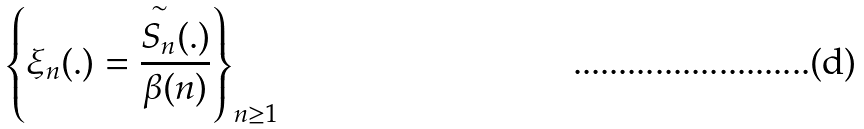<formula> <loc_0><loc_0><loc_500><loc_500>\left \{ \xi _ { n } ( . ) = \frac { \overset { \sim } { S _ { n } } ( . ) } { \beta ( n ) } \right \} _ { n \geq 1 }</formula> 